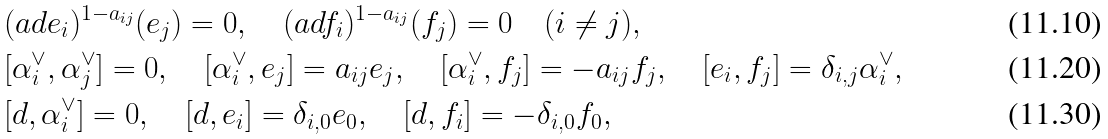Convert formula to latex. <formula><loc_0><loc_0><loc_500><loc_500>& ( a d e _ { i } ) ^ { 1 - a _ { i j } } ( e _ { j } ) = 0 , \quad ( a d f _ { i } ) ^ { 1 - a _ { i j } } ( f _ { j } ) = 0 \quad ( i \neq j ) , \\ & [ \alpha _ { i } ^ { \vee } , \alpha _ { j } ^ { \vee } ] = 0 , \quad [ \alpha _ { i } ^ { \vee } , e _ { j } ] = a _ { i j } e _ { j } , \quad [ \alpha _ { i } ^ { \vee } , f _ { j } ] = - a _ { i j } f _ { j } , \quad [ e _ { i } , f _ { j } ] = \delta _ { i , j } \alpha _ { i } ^ { \vee } , \\ & [ d , \alpha _ { i } ^ { \vee } ] = 0 , \quad [ d , e _ { i } ] = \delta _ { i , 0 } e _ { 0 } , \quad [ d , f _ { i } ] = - \delta _ { i , 0 } f _ { 0 } ,</formula> 